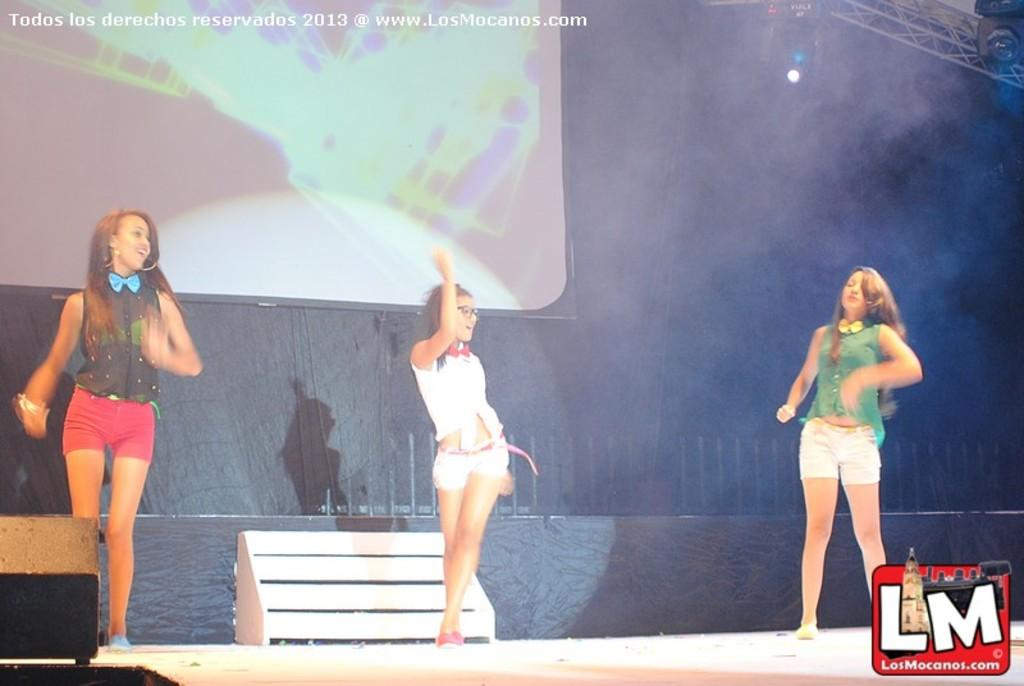What are the women in the image doing? The women are performing in the image. Where are the women performing? They are on a dais. What can be seen on the wall in the background? There is a display screen on the wall in the background. What architectural features are present in the background? There are iron grills in the background. What type of lighting is present in the background? Electric lights are present in the background. What type of bean is being used as a prop by the women in the image? There is no bean present in the image; the women are performing without any such prop. 